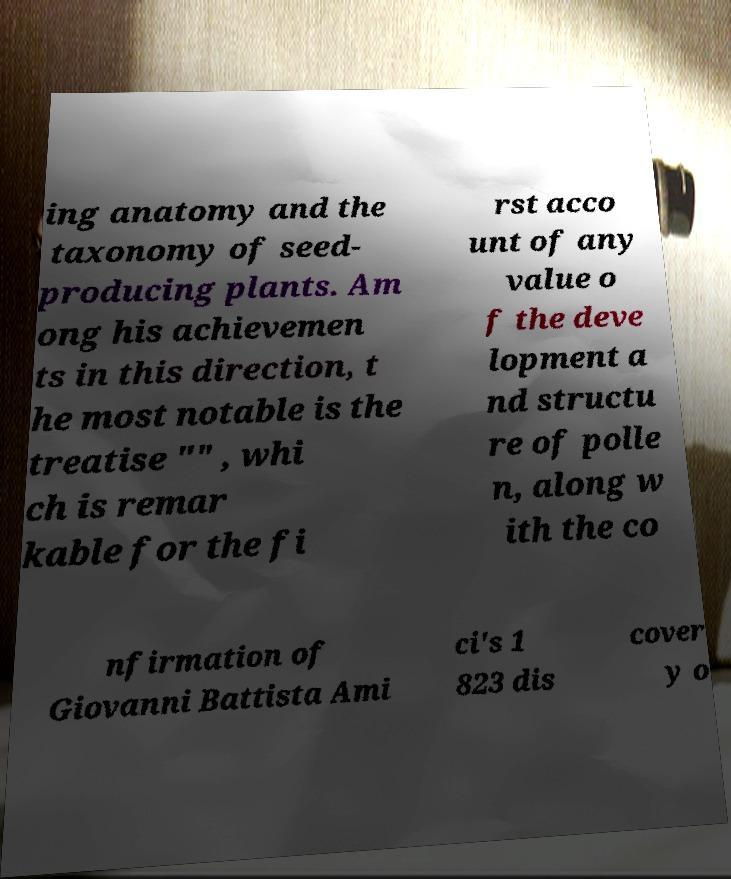Could you assist in decoding the text presented in this image and type it out clearly? ing anatomy and the taxonomy of seed- producing plants. Am ong his achievemen ts in this direction, t he most notable is the treatise "" , whi ch is remar kable for the fi rst acco unt of any value o f the deve lopment a nd structu re of polle n, along w ith the co nfirmation of Giovanni Battista Ami ci's 1 823 dis cover y o 